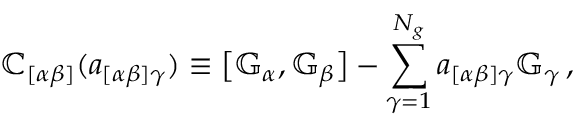Convert formula to latex. <formula><loc_0><loc_0><loc_500><loc_500>\mathbb { C } _ { [ \alpha \beta ] } ( a _ { [ \alpha \beta ] \gamma } ) \equiv \left [ \mathbb { G } _ { \alpha } , \mathbb { G } _ { \beta } \right ] - \sum _ { \gamma = 1 } ^ { N _ { g } } a _ { [ \alpha \beta ] \gamma } \mathbb { G } _ { \gamma } \, ,</formula> 